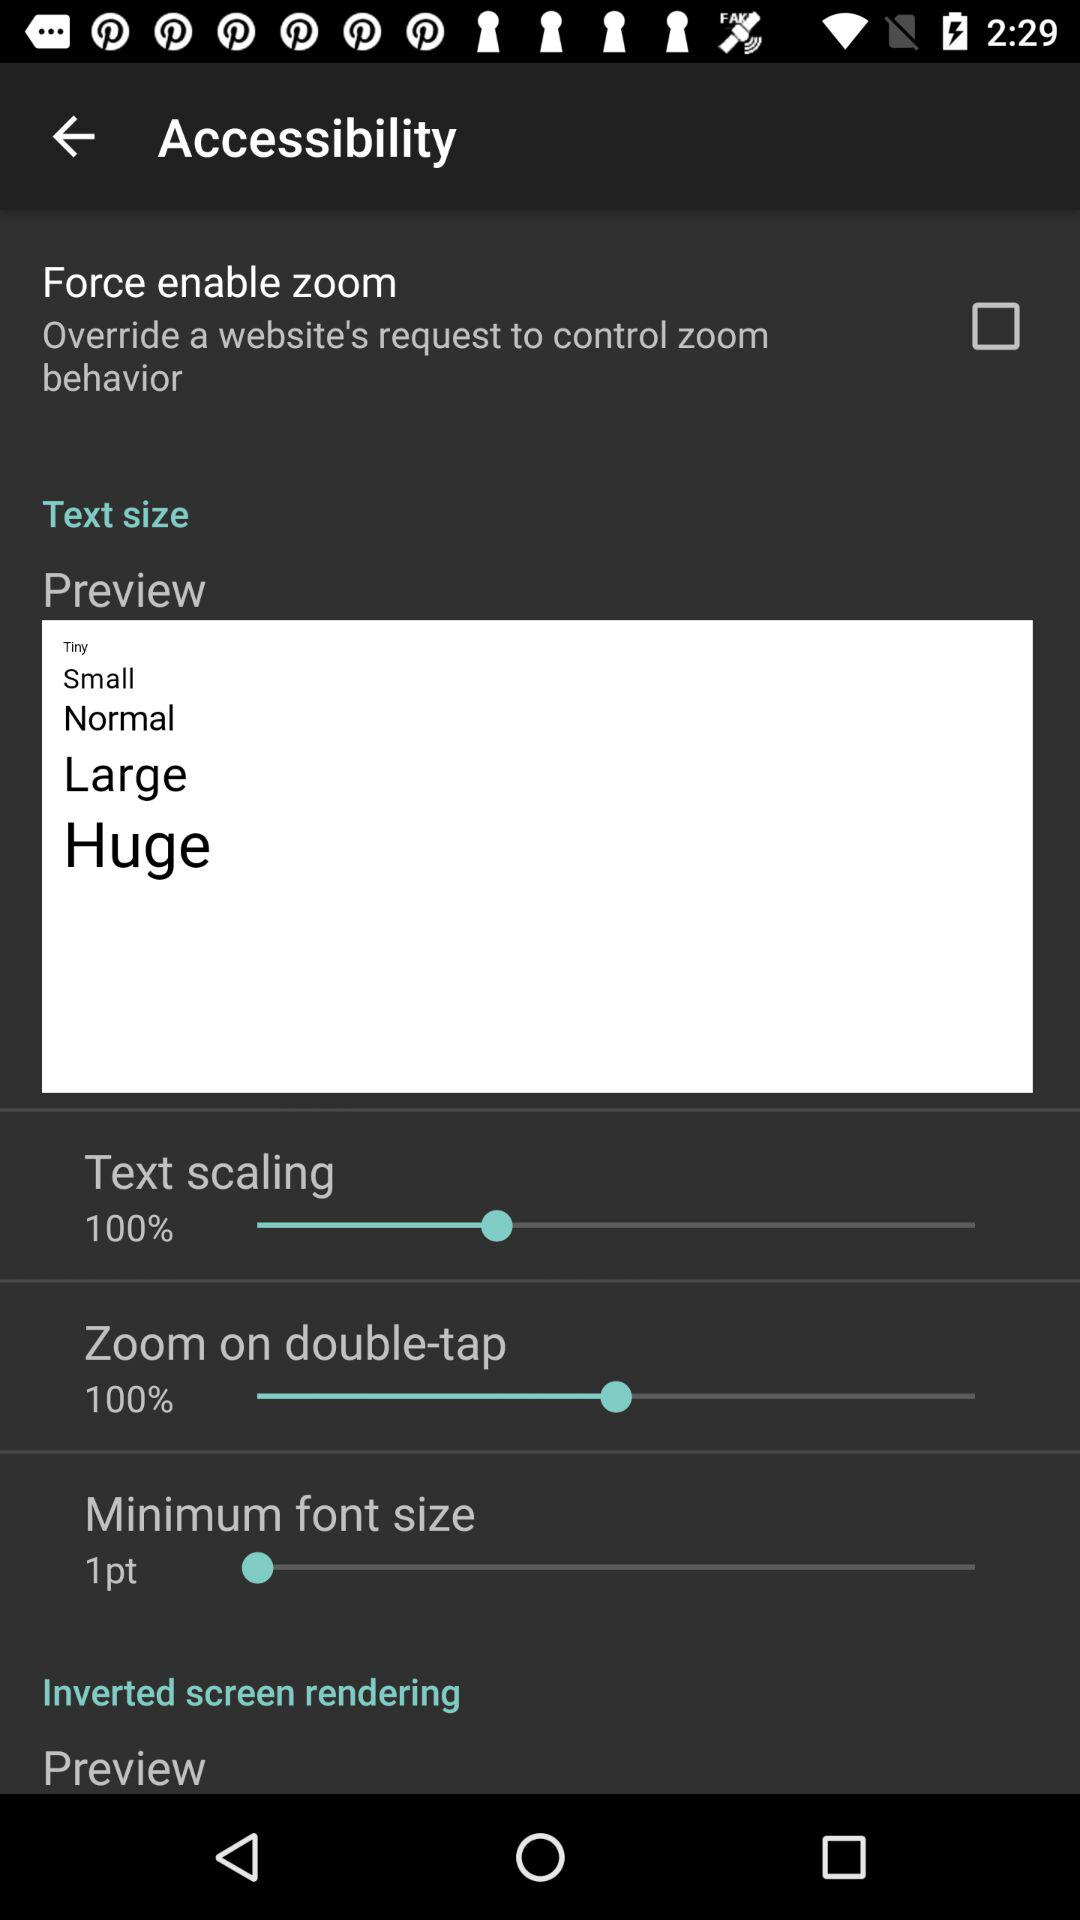What options are given in "Text size"? The options are "Preview", "Text scaling", "Zoom on double-tap" and "Minimum font size". 